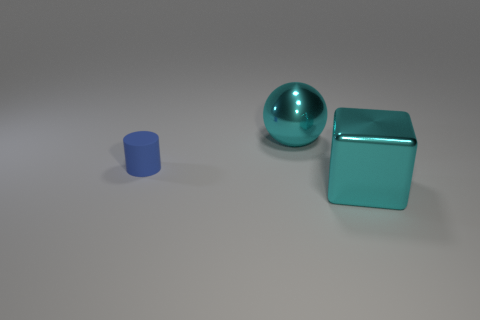Do the large ball and the metal block have the same color?
Offer a very short reply. Yes. What shape is the thing that is in front of the big ball and behind the cyan metal block?
Offer a terse response. Cylinder. There is a metal object left of the large metallic thing in front of the small cylinder; is there a large cyan object in front of it?
Keep it short and to the point. Yes. How many other objects are there of the same material as the cyan ball?
Your response must be concise. 1. What number of shiny things are there?
Your response must be concise. 2. How many objects are either purple metallic spheres or things that are in front of the big shiny ball?
Your answer should be compact. 2. Is there any other thing that is the same shape as the small object?
Offer a very short reply. No. There is a cyan object that is in front of the matte cylinder; is its size the same as the blue matte object?
Give a very brief answer. No. How many metallic things are tiny objects or big purple balls?
Your answer should be compact. 0. There is a cyan thing left of the large cyan block; what is its size?
Keep it short and to the point. Large. 